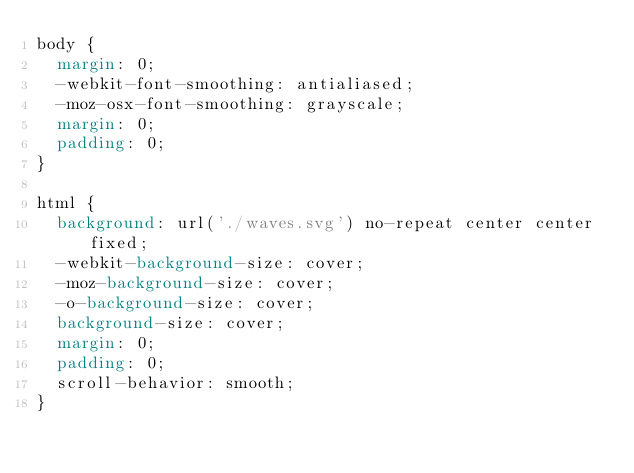Convert code to text. <code><loc_0><loc_0><loc_500><loc_500><_CSS_>body {
  margin: 0;
  -webkit-font-smoothing: antialiased;
  -moz-osx-font-smoothing: grayscale;
  margin: 0;
  padding: 0;
}

html {
  background: url('./waves.svg') no-repeat center center fixed; 
  -webkit-background-size: cover;
  -moz-background-size: cover;
  -o-background-size: cover;
  background-size: cover;
  margin: 0;
  padding: 0;
  scroll-behavior: smooth;
}
</code> 